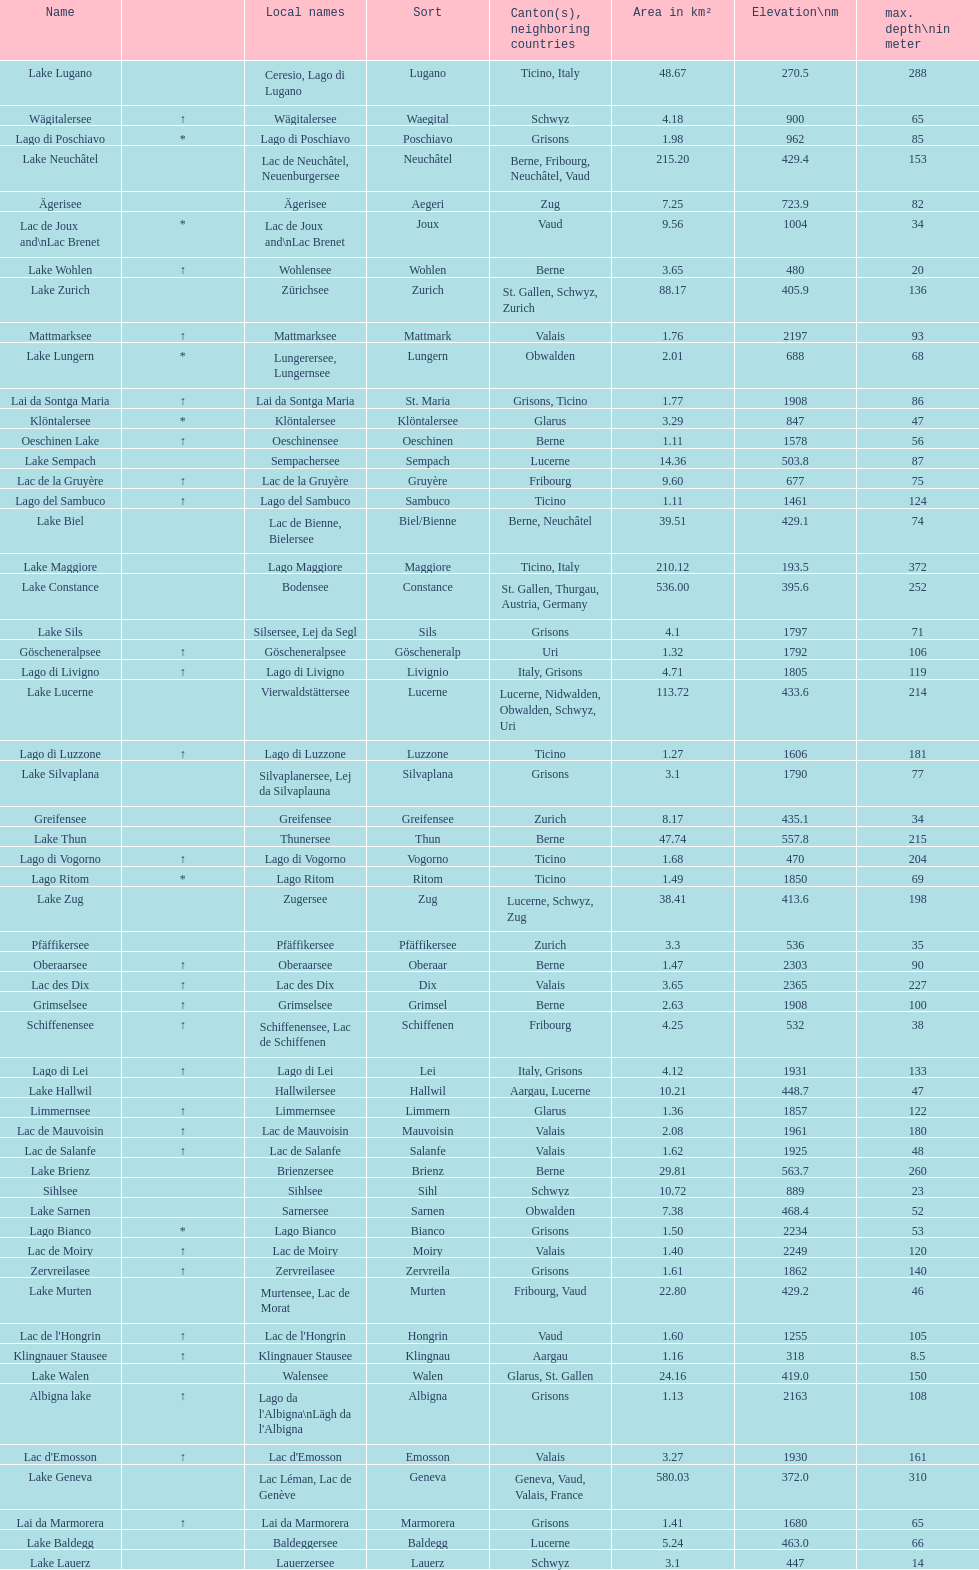Name the largest lake Lake Geneva. 